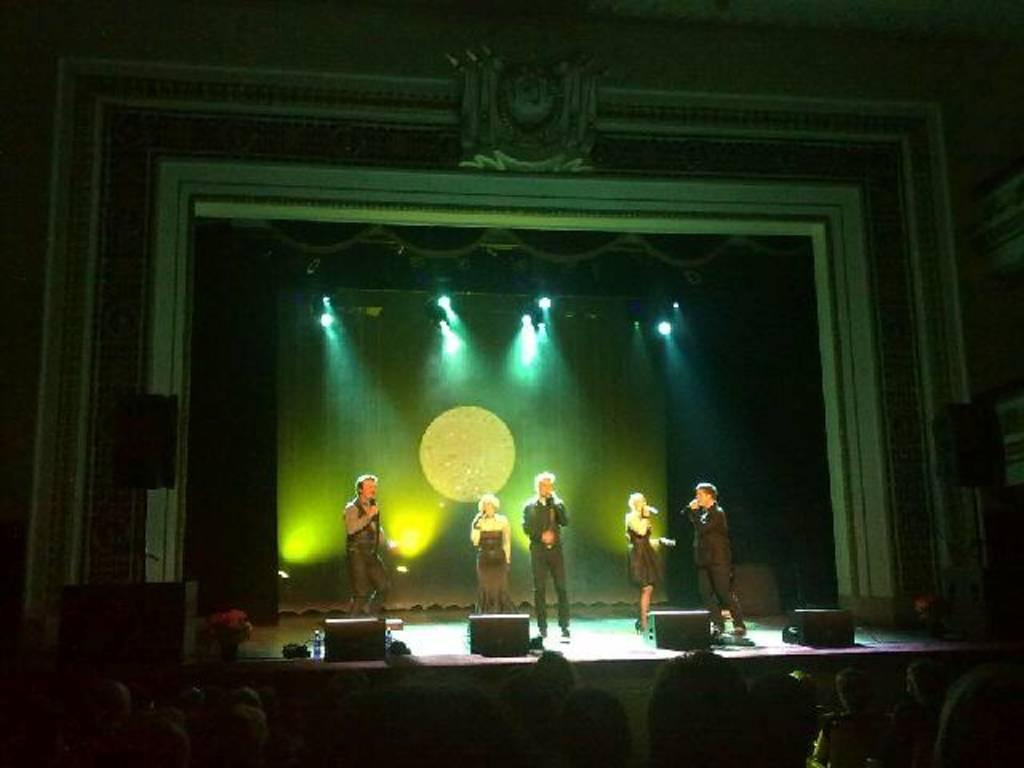What are the people on stage doing in the image? The people on stage are holding microphones, which suggests they might be performing or giving a speech. What can be seen in the background of the image? There are lights visible in the image, which could be stage lights or other illumination. What are the people in the foreground doing? The people in the foreground are sitting on chairs, which might indicate they are watching a performance or event. What type of wound can be seen on the string in the image? There is no wound or string present in the image. What kind of amusement park ride is visible in the image? There is no amusement park ride visible in the image; it features people on stage and in the foreground. 